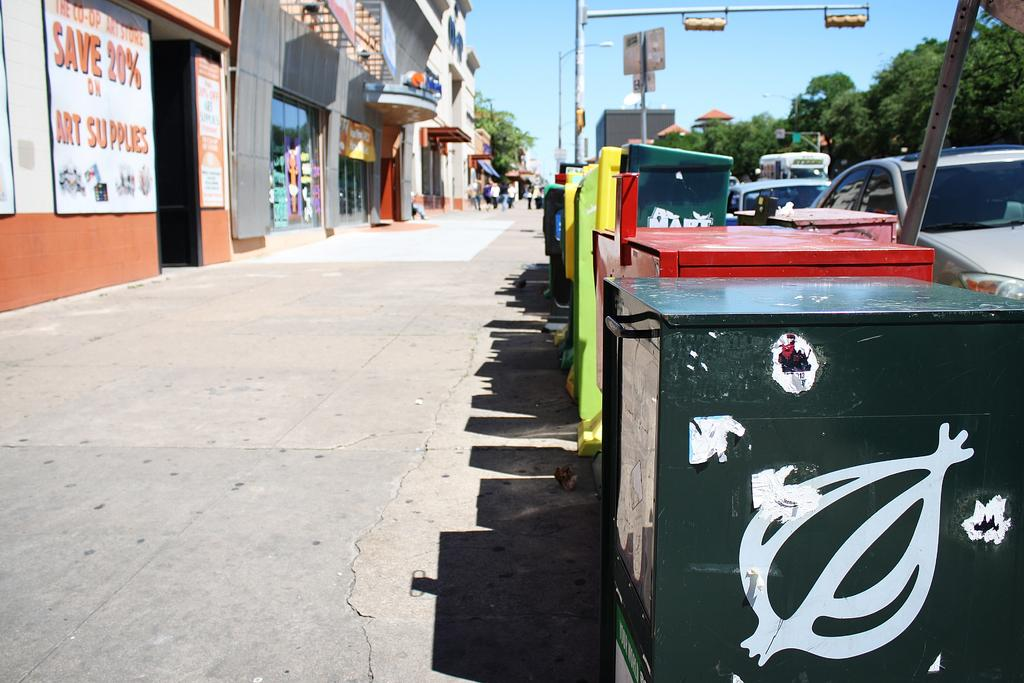<image>
Give a short and clear explanation of the subsequent image. A sign on the side of a building advertises saving 20% on art supplies. 